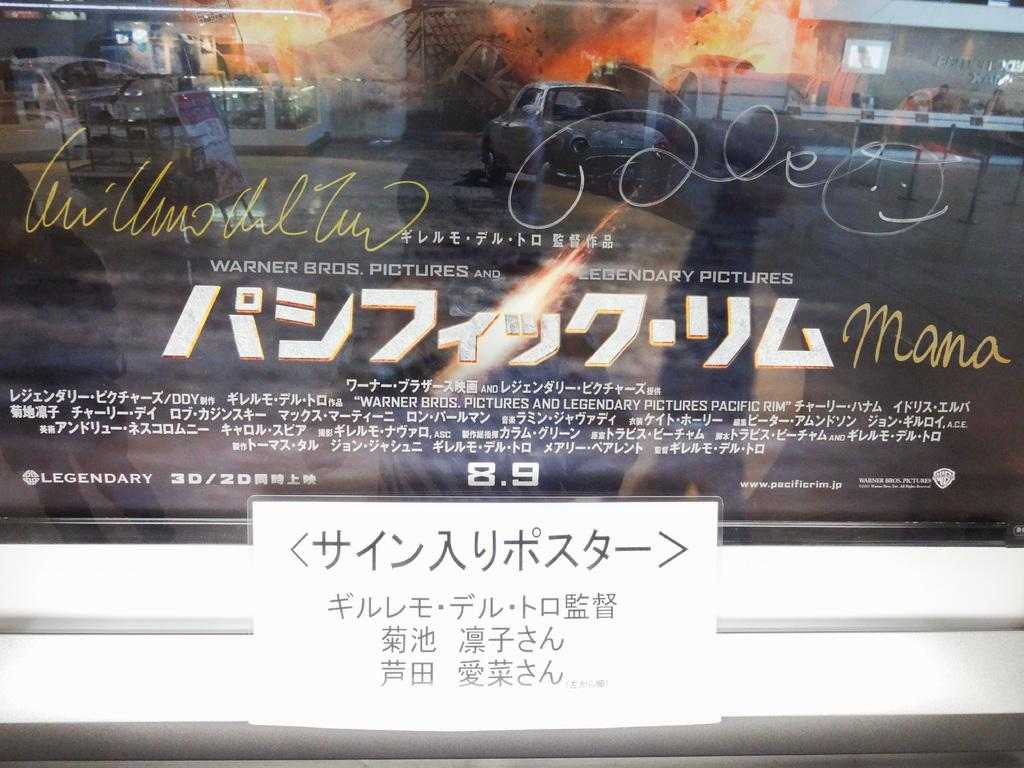<image>
Provide a brief description of the given image. Warner brothers pictures and legendary pictures Mama poster. 